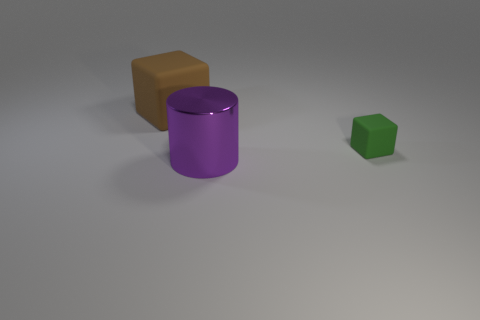Add 3 tiny metal cubes. How many objects exist? 6 Subtract all blocks. How many objects are left? 1 Add 2 gray shiny cylinders. How many gray shiny cylinders exist? 2 Subtract 1 brown cubes. How many objects are left? 2 Subtract all purple things. Subtract all brown rubber objects. How many objects are left? 1 Add 1 small cubes. How many small cubes are left? 2 